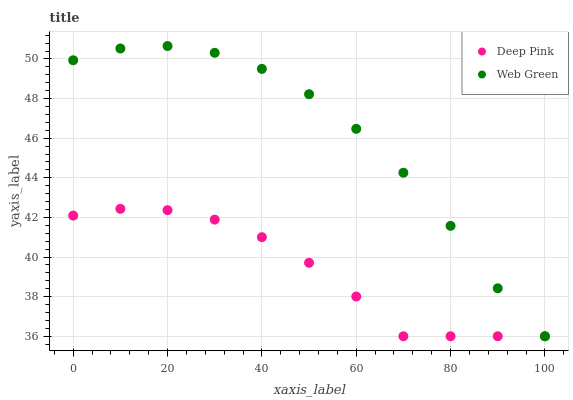Does Deep Pink have the minimum area under the curve?
Answer yes or no. Yes. Does Web Green have the maximum area under the curve?
Answer yes or no. Yes. Does Web Green have the minimum area under the curve?
Answer yes or no. No. Is Deep Pink the smoothest?
Answer yes or no. Yes. Is Web Green the roughest?
Answer yes or no. Yes. Is Web Green the smoothest?
Answer yes or no. No. Does Deep Pink have the lowest value?
Answer yes or no. Yes. Does Web Green have the highest value?
Answer yes or no. Yes. Does Web Green intersect Deep Pink?
Answer yes or no. Yes. Is Web Green less than Deep Pink?
Answer yes or no. No. Is Web Green greater than Deep Pink?
Answer yes or no. No. 